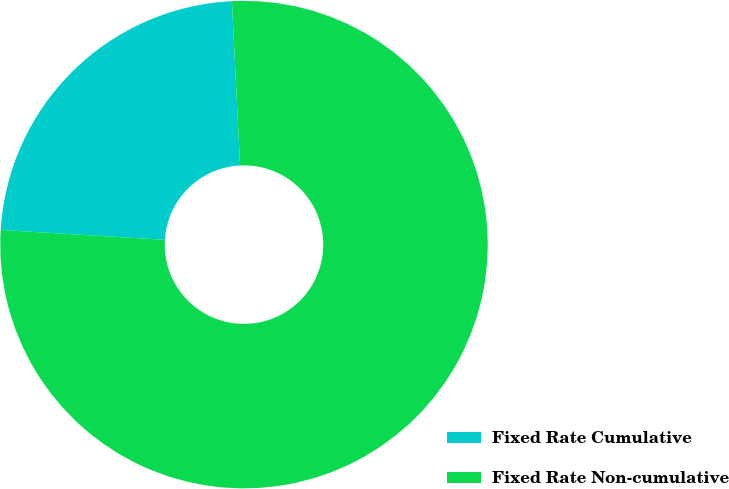Convert chart to OTSL. <chart><loc_0><loc_0><loc_500><loc_500><pie_chart><fcel>Fixed Rate Cumulative<fcel>Fixed Rate Non-cumulative<nl><fcel>23.25%<fcel>76.75%<nl></chart> 